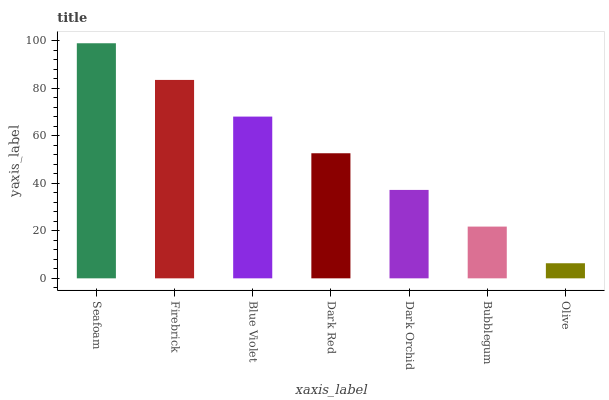Is Olive the minimum?
Answer yes or no. Yes. Is Seafoam the maximum?
Answer yes or no. Yes. Is Firebrick the minimum?
Answer yes or no. No. Is Firebrick the maximum?
Answer yes or no. No. Is Seafoam greater than Firebrick?
Answer yes or no. Yes. Is Firebrick less than Seafoam?
Answer yes or no. Yes. Is Firebrick greater than Seafoam?
Answer yes or no. No. Is Seafoam less than Firebrick?
Answer yes or no. No. Is Dark Red the high median?
Answer yes or no. Yes. Is Dark Red the low median?
Answer yes or no. Yes. Is Olive the high median?
Answer yes or no. No. Is Seafoam the low median?
Answer yes or no. No. 